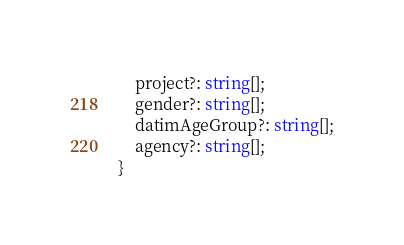<code> <loc_0><loc_0><loc_500><loc_500><_TypeScript_>    project?: string[];
    gender?: string[];
    datimAgeGroup?: string[];
    agency?: string[];
}
</code> 